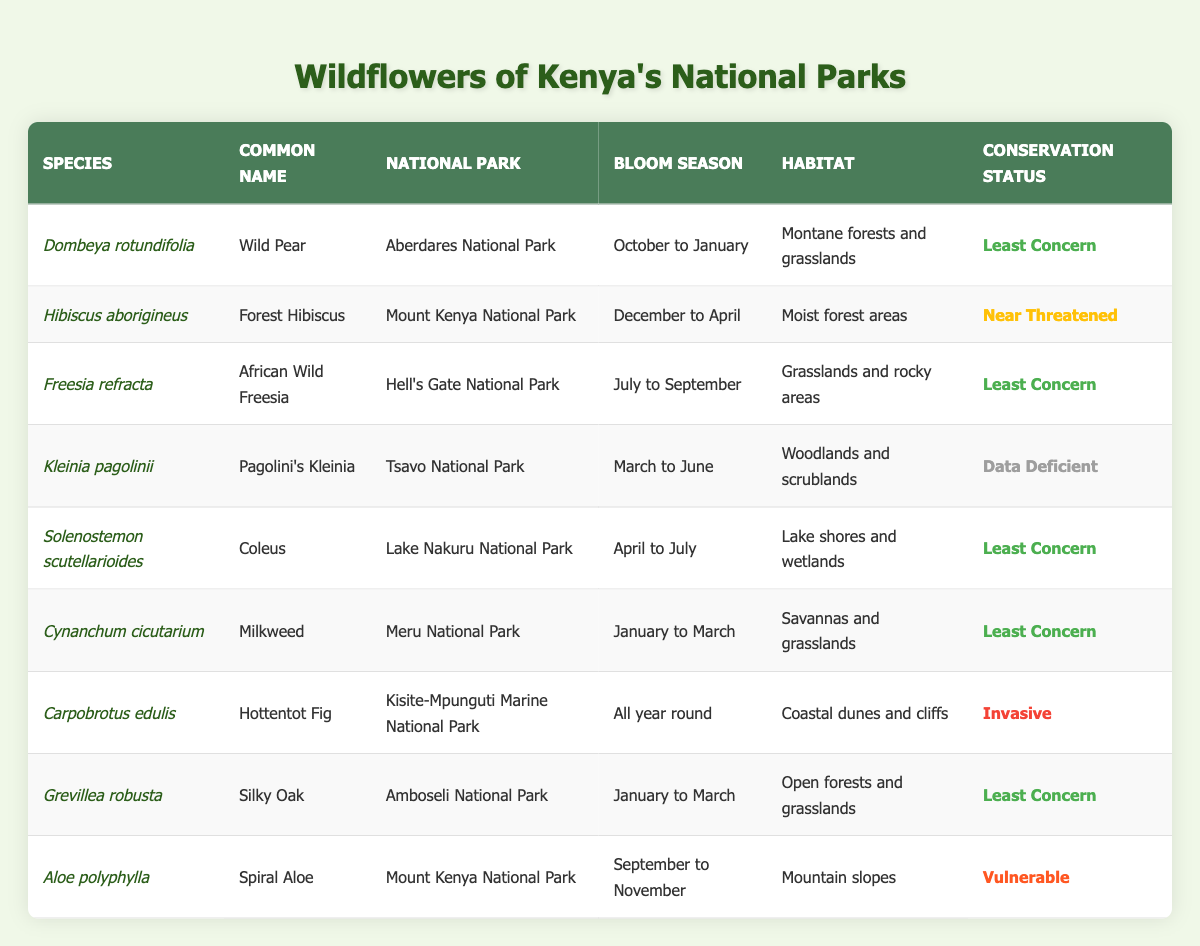What is the conservation status of Aloe polyphylla? The table shows that Aloe polyphylla has a conservation status of "Vulnerable." You can find this information in the last row of the table under the "Conservation Status" column.
Answer: Vulnerable Which national park has the species with the common name "Coleus"? Referring to the table, the common name "Coleus" corresponds to the species Solenostemon scutellarioides, which is found in Lake Nakuru National Park. This is noted in the "National Park" column of the same row.
Answer: Lake Nakuru National Park What is the bloom season for Hibiscus aborigineus? The table lists the bloom season for Hibiscus aborigineus as "December to April." This is located in the same row as the species name under the "Bloom Season" column.
Answer: December to April How many wildflower species bloom between January and March? The species that bloom from January to March are Dombeya rotundifolia, Cynanchum cicutarium, and Grevillea robusta. This provides a total of 3 species. You can identify them by checking the bloom seasons listed in the table.
Answer: 3 Is the conservation status of Freesia refracta "Least Concern"? Yes, the conservation status of Freesia refracta is listed as "Least Concern" in the table. You would refer to the row corresponding to Freesia refracta for this information.
Answer: Yes Identify the species found in Mount Kenya National Park that has a "Near Threatened" conservation status. The species found in Mount Kenya National Park are Hibiscus aborigineus and Aloe polyphylla. Among these, Hibiscus aborigineus has a conservation status of "Near Threatened." This identification is made by cross-referencing the park name and conservation status columns.
Answer: Hibiscus aborigineus Which national parks host species that bloom all year round? The only species listed that blooms all year round is Carpobrotus edulis, located in Kisite-Mpunguti Marine National Park. By examining the “Bloom Season” column, you can spot this specific entry.
Answer: Kisite-Mpunguti Marine National Park Are there any invasive species listed in the table? Yes, the table includes Carpobrotus edulis labeled as an "Invasive" species under the conservation status. This can be confirmed by checking the designation in the respective column.
Answer: Yes What is the total number of wildflower species listed that have a bloom season in March or April? The species that bloom in March are Kleinia pagolinii, Grevillea robusta, and Cynanchum cicutarium, while those that bloom in April are Solenostemon scutellarioides and Hibiscus aborigineus. Thus, the total number is 5 species. You can find them by reviewing the bloom season entries related to these months.
Answer: 5 Which two wildflower species have their bloom seasons overlapping in January? The two wildflower species with bloom seasons that overlap in January are Dombeya rotundifolia and Cynanchum cicutarium. This is derived from analyzing the bloom seasons and identifying both occurring in January.
Answer: Dombeya rotundifolia and Cynanchum cicutarium What is the common name for the species with the scientific name "Grevillea robusta"? The common name for Grevillea robusta, according to the table, is "Silky Oak." You can find this in the corresponding row under the "Common Name" column.
Answer: Silky Oak 